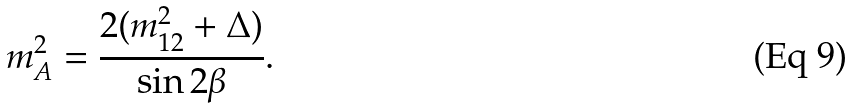<formula> <loc_0><loc_0><loc_500><loc_500>m _ { A } ^ { 2 } = \frac { 2 ( m _ { 1 2 } ^ { 2 } + \Delta ) } { \sin 2 \beta } .</formula> 